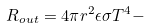<formula> <loc_0><loc_0><loc_500><loc_500>R _ { o u t } = 4 \pi r ^ { 2 } \epsilon \sigma T ^ { 4 } -</formula> 